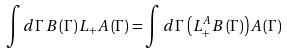Convert formula to latex. <formula><loc_0><loc_0><loc_500><loc_500>\int d \Gamma \, B \left ( \Gamma \right ) L _ { + } A \left ( \Gamma \right ) = \int d \Gamma \, \left ( L _ { + } ^ { A } B \left ( \Gamma \right ) \right ) A \left ( \Gamma \right )</formula> 